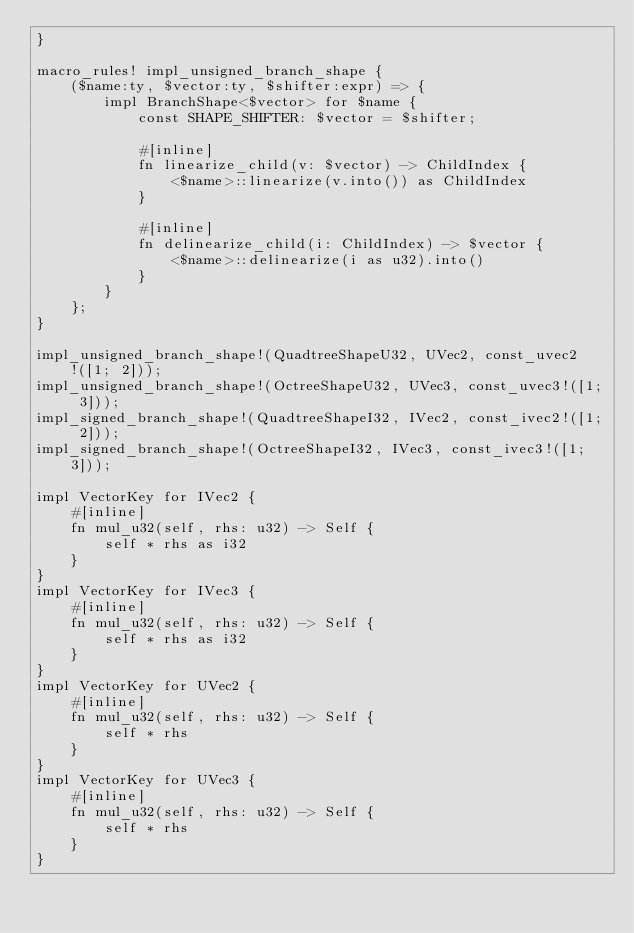Convert code to text. <code><loc_0><loc_0><loc_500><loc_500><_Rust_>}

macro_rules! impl_unsigned_branch_shape {
    ($name:ty, $vector:ty, $shifter:expr) => {
        impl BranchShape<$vector> for $name {
            const SHAPE_SHIFTER: $vector = $shifter;

            #[inline]
            fn linearize_child(v: $vector) -> ChildIndex {
                <$name>::linearize(v.into()) as ChildIndex
            }

            #[inline]
            fn delinearize_child(i: ChildIndex) -> $vector {
                <$name>::delinearize(i as u32).into()
            }
        }
    };
}

impl_unsigned_branch_shape!(QuadtreeShapeU32, UVec2, const_uvec2!([1; 2]));
impl_unsigned_branch_shape!(OctreeShapeU32, UVec3, const_uvec3!([1; 3]));
impl_signed_branch_shape!(QuadtreeShapeI32, IVec2, const_ivec2!([1; 2]));
impl_signed_branch_shape!(OctreeShapeI32, IVec3, const_ivec3!([1; 3]));

impl VectorKey for IVec2 {
    #[inline]
    fn mul_u32(self, rhs: u32) -> Self {
        self * rhs as i32
    }
}
impl VectorKey for IVec3 {
    #[inline]
    fn mul_u32(self, rhs: u32) -> Self {
        self * rhs as i32
    }
}
impl VectorKey for UVec2 {
    #[inline]
    fn mul_u32(self, rhs: u32) -> Self {
        self * rhs
    }
}
impl VectorKey for UVec3 {
    #[inline]
    fn mul_u32(self, rhs: u32) -> Self {
        self * rhs
    }
}
</code> 